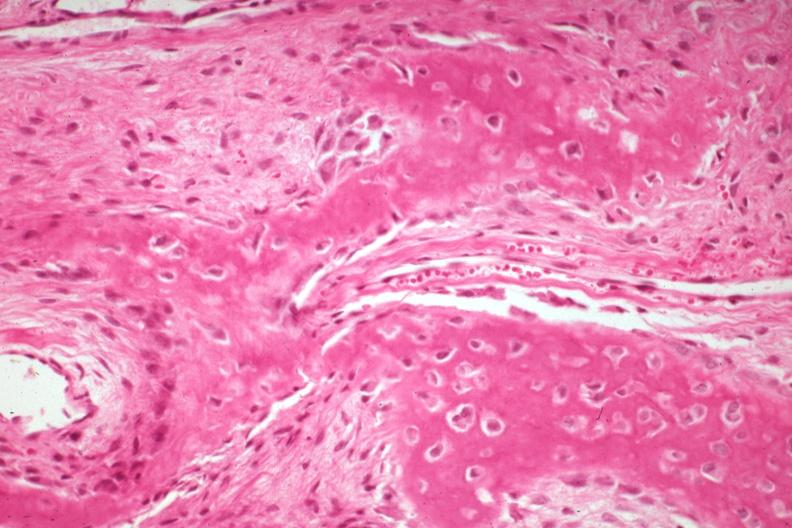what is present?
Answer the question using a single word or phrase. Joints 